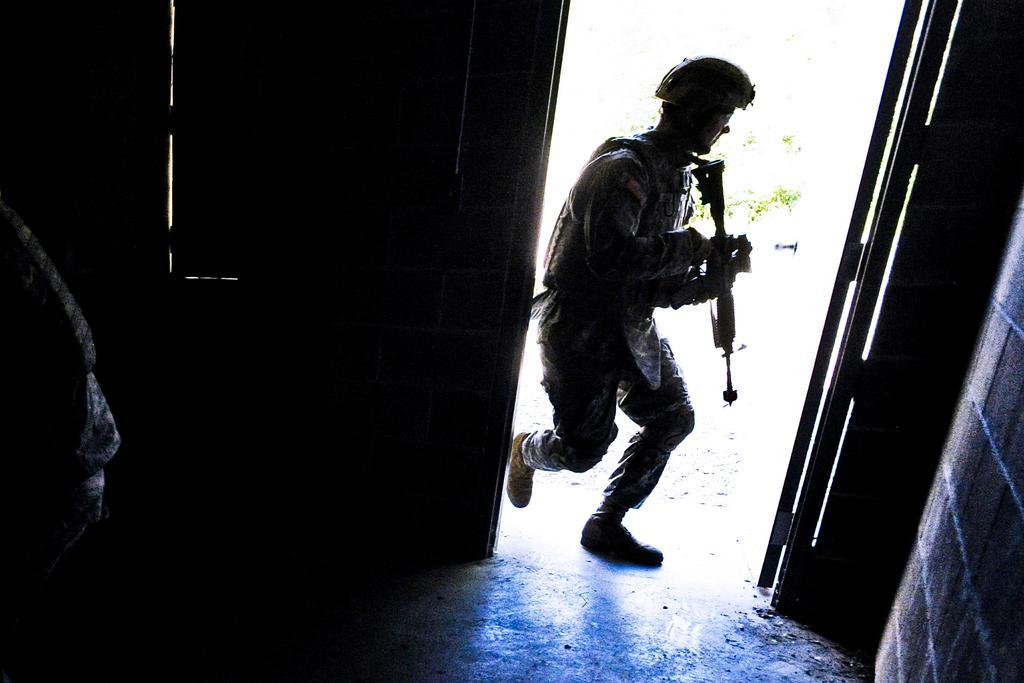Describe this image in one or two sentences. In this picture I can see a person is holding a gun in the hand and wearing a helmet. On the right side I can see a wall. 